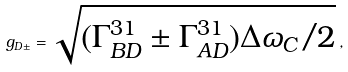Convert formula to latex. <formula><loc_0><loc_0><loc_500><loc_500>g _ { D \pm } = \sqrt { ( \Gamma ^ { 3 1 } _ { B D } \pm \Gamma ^ { 3 1 } _ { A D } ) \Delta \omega _ { C } / 2 } \, ,</formula> 